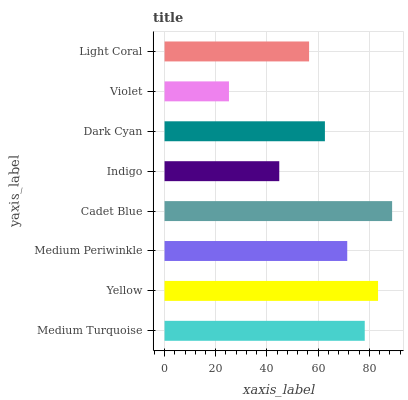Is Violet the minimum?
Answer yes or no. Yes. Is Cadet Blue the maximum?
Answer yes or no. Yes. Is Yellow the minimum?
Answer yes or no. No. Is Yellow the maximum?
Answer yes or no. No. Is Yellow greater than Medium Turquoise?
Answer yes or no. Yes. Is Medium Turquoise less than Yellow?
Answer yes or no. Yes. Is Medium Turquoise greater than Yellow?
Answer yes or no. No. Is Yellow less than Medium Turquoise?
Answer yes or no. No. Is Medium Periwinkle the high median?
Answer yes or no. Yes. Is Dark Cyan the low median?
Answer yes or no. Yes. Is Light Coral the high median?
Answer yes or no. No. Is Light Coral the low median?
Answer yes or no. No. 